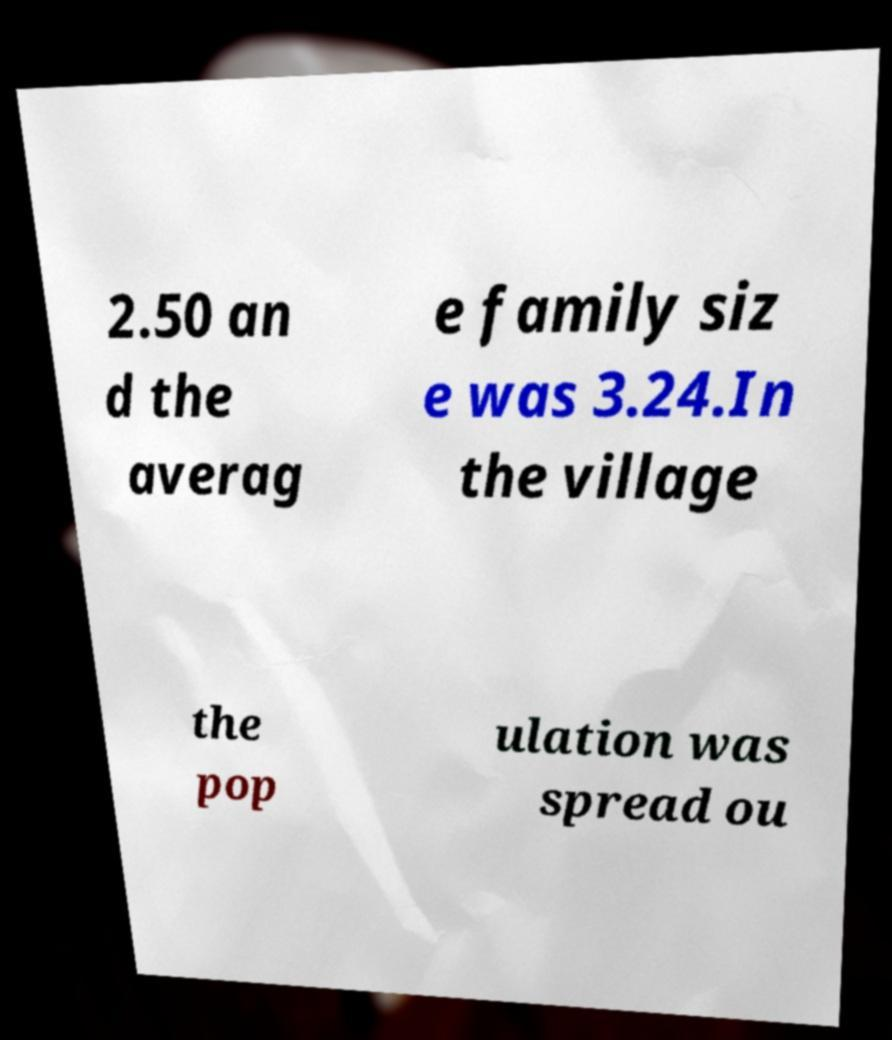Could you assist in decoding the text presented in this image and type it out clearly? 2.50 an d the averag e family siz e was 3.24.In the village the pop ulation was spread ou 